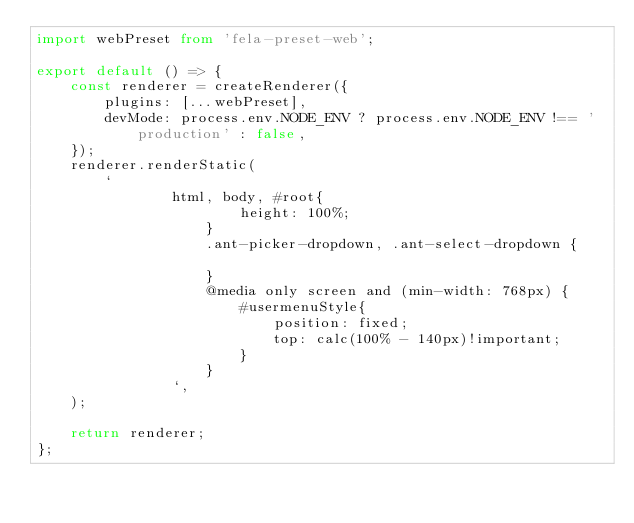Convert code to text. <code><loc_0><loc_0><loc_500><loc_500><_TypeScript_>import webPreset from 'fela-preset-web';

export default () => {
    const renderer = createRenderer({
        plugins: [...webPreset],
        devMode: process.env.NODE_ENV ? process.env.NODE_ENV !== 'production' : false,
    });
    renderer.renderStatic(
        `
				html, body, #root{
						height: 100%;
					}
					.ant-picker-dropdown, .ant-select-dropdown {
						
					}
					@media only screen and (min-width: 768px) {
						#usermenuStyle{
							position: fixed;
							top: calc(100% - 140px)!important;
						}
					}
				`,
    );

    return renderer;
};
</code> 